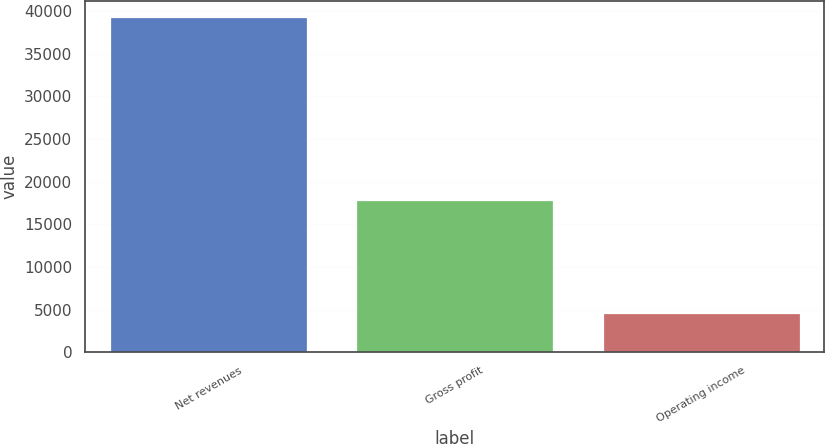<chart> <loc_0><loc_0><loc_500><loc_500><bar_chart><fcel>Net revenues<fcel>Gross profit<fcel>Operating income<nl><fcel>39267<fcel>17883<fcel>4541<nl></chart> 